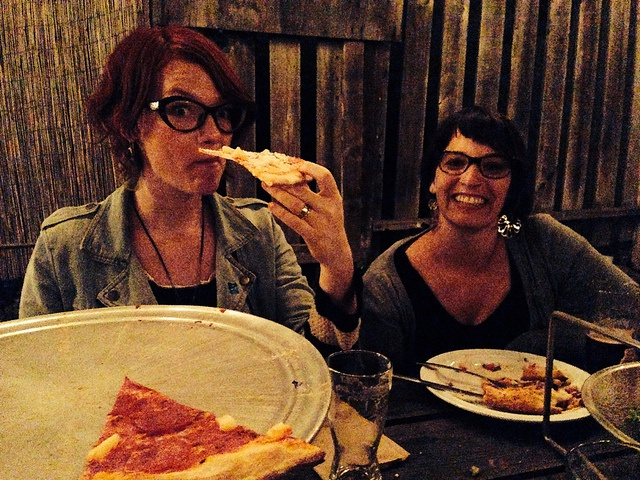Describe the objects in this image and their specific colors. I can see people in black, maroon, and brown tones, people in black, maroon, and brown tones, dining table in black, maroon, and brown tones, pizza in black, brown, red, and orange tones, and cup in black, red, and maroon tones in this image. 